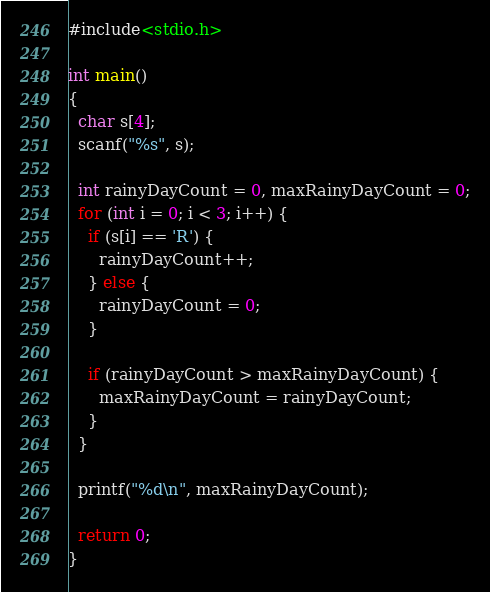<code> <loc_0><loc_0><loc_500><loc_500><_C_>#include<stdio.h>

int main()
{
  char s[4];
  scanf("%s", s);
  
  int rainyDayCount = 0, maxRainyDayCount = 0;
  for (int i = 0; i < 3; i++) {
    if (s[i] == 'R') {
      rainyDayCount++;
    } else {
      rainyDayCount = 0;
    }
    
    if (rainyDayCount > maxRainyDayCount) {
      maxRainyDayCount = rainyDayCount;
    }
  }
  
  printf("%d\n", maxRainyDayCount);
  
  return 0;
}</code> 